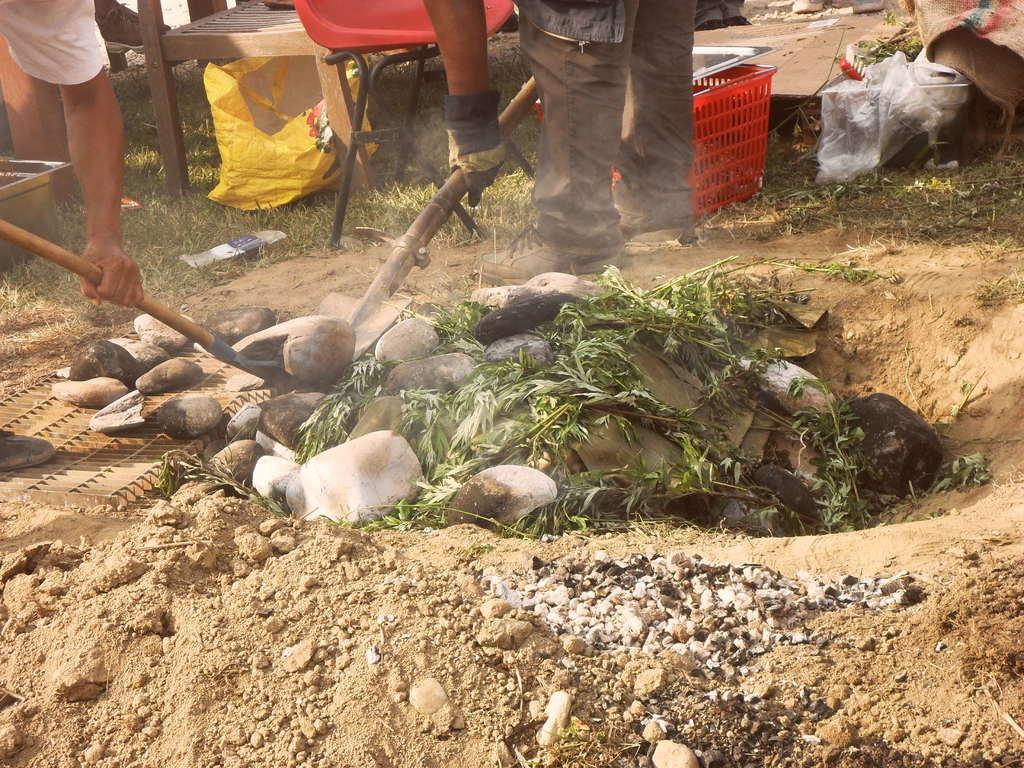How many people are in the image? There are two persons in the image. What are the persons holding in their hands? The persons are holding tools. What is in front of the persons? There are rocks in front of the persons. What type of furniture is beside the persons? There are chairs beside the persons. What protective material is present in the image? There are plastic covers in the image. What type of container is in the image? There is a bowl in the image. What type of carrying device is in the image? There is a basket in the image. What type of party is happening in the image? There is no party happening in the image; it shows two persons holding tools and other objects. What time of day is depicted in the image? The time of day cannot be determined from the image alone. 